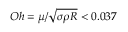Convert formula to latex. <formula><loc_0><loc_0><loc_500><loc_500>O h = \mu / \sqrt { \sigma \rho R } < 0 . 0 3 7</formula> 